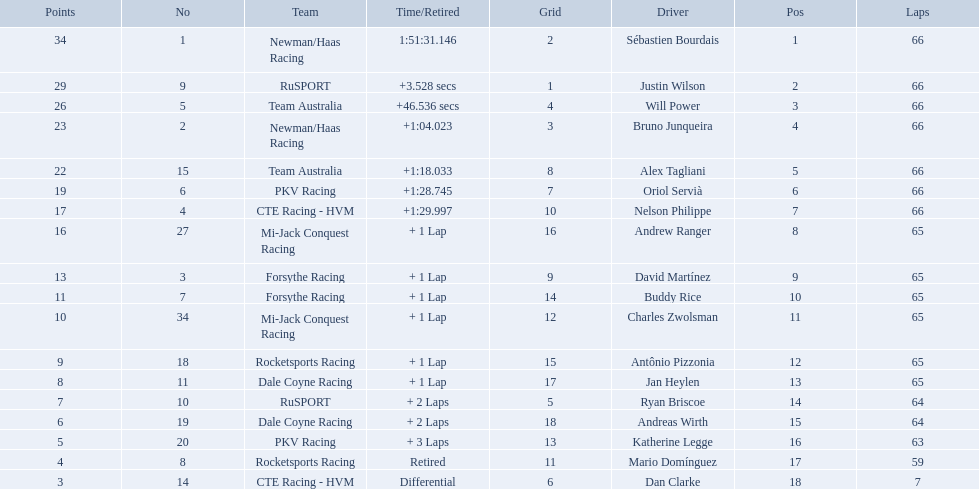What was the highest amount of points scored in the 2006 gran premio? 34. Who scored 34 points? Sébastien Bourdais. Who are all of the 2006 gran premio telmex drivers? Sébastien Bourdais, Justin Wilson, Will Power, Bruno Junqueira, Alex Tagliani, Oriol Servià, Nelson Philippe, Andrew Ranger, David Martínez, Buddy Rice, Charles Zwolsman, Antônio Pizzonia, Jan Heylen, Ryan Briscoe, Andreas Wirth, Katherine Legge, Mario Domínguez, Dan Clarke. How many laps did they finish? 66, 66, 66, 66, 66, 66, 66, 65, 65, 65, 65, 65, 65, 64, 64, 63, 59, 7. What about just oriol servia and katherine legge? 66, 63. And which of those two drivers finished more laps? Oriol Servià. Which drivers scored at least 10 points? Sébastien Bourdais, Justin Wilson, Will Power, Bruno Junqueira, Alex Tagliani, Oriol Servià, Nelson Philippe, Andrew Ranger, David Martínez, Buddy Rice, Charles Zwolsman. Of those drivers, which ones scored at least 20 points? Sébastien Bourdais, Justin Wilson, Will Power, Bruno Junqueira, Alex Tagliani. Of those 5, which driver scored the most points? Sébastien Bourdais. 